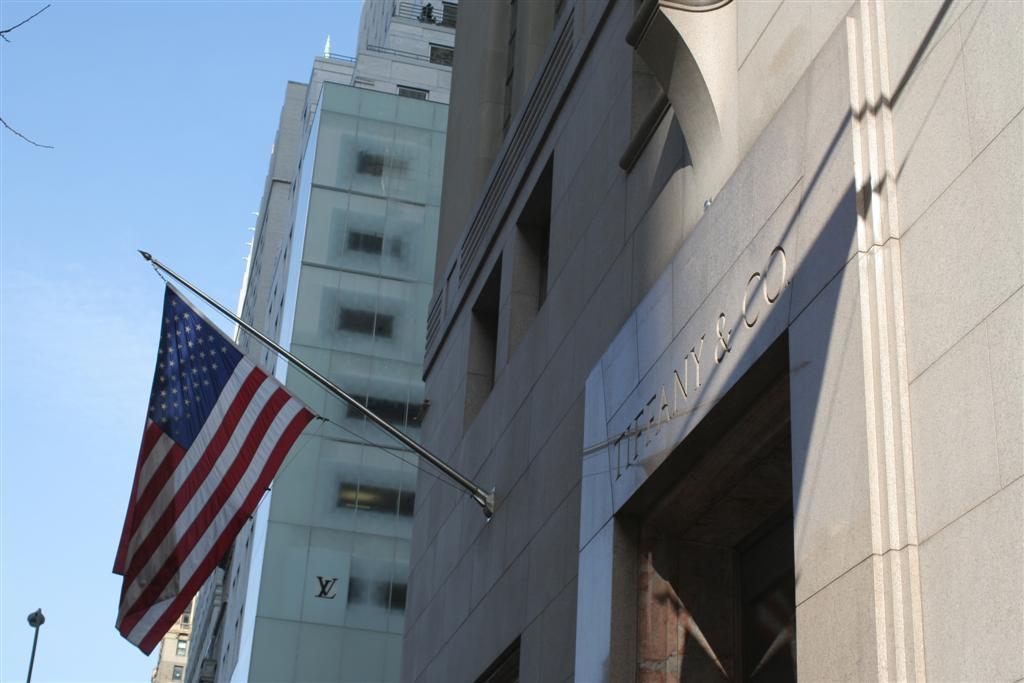Could you give a brief overview of what you see in this image? In this picture we can see buildings and on the building there is a name board and a pole with a flag. On the left side of the buildings there is a pole and branches. Behind the buildings there is the sky. 